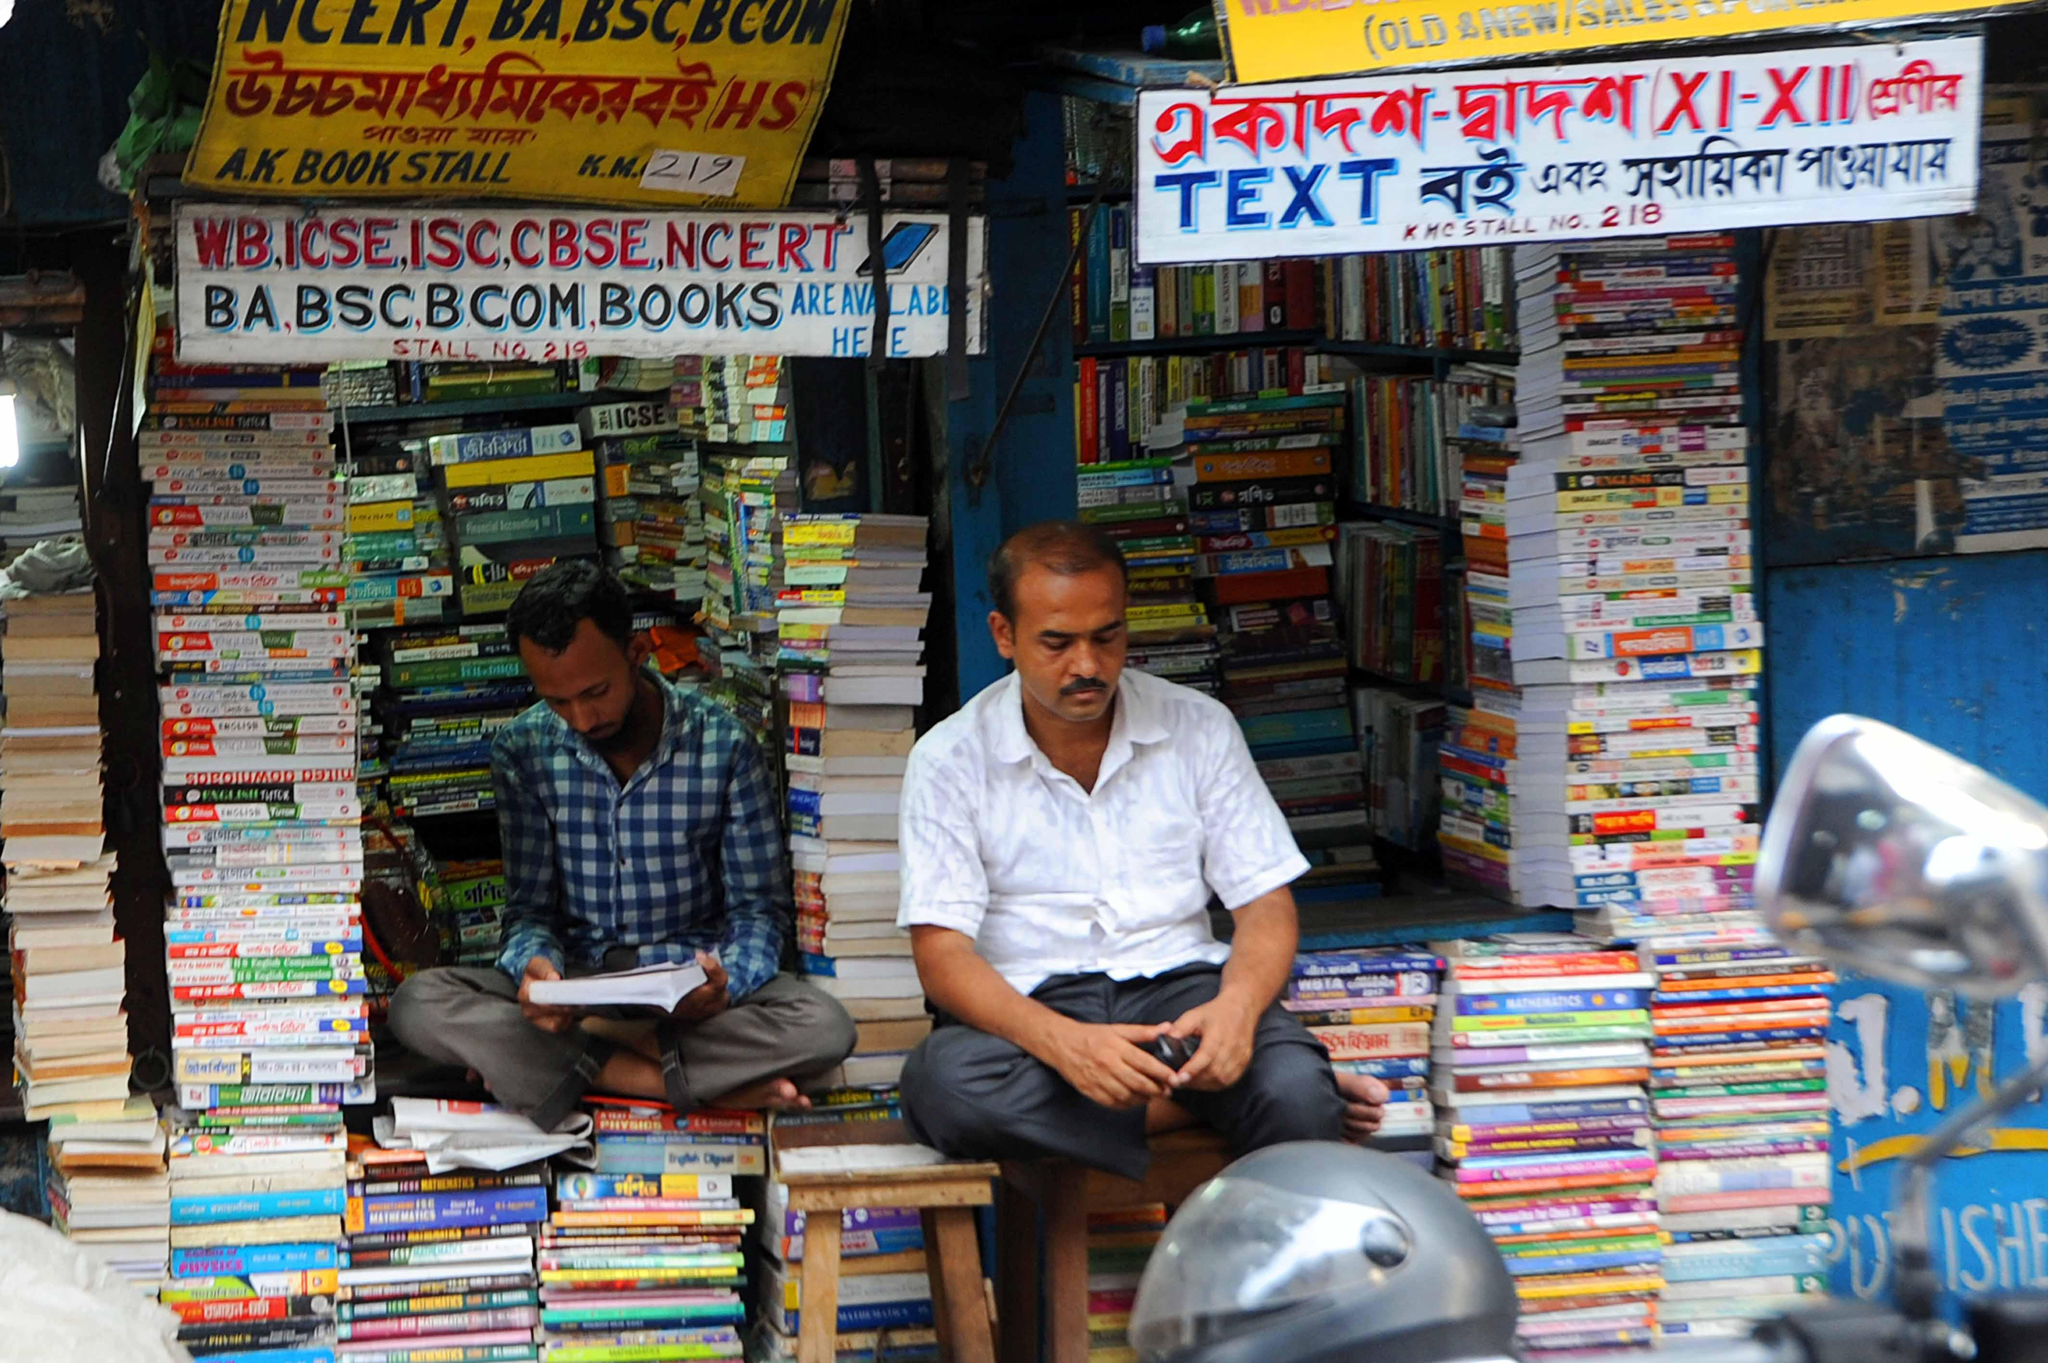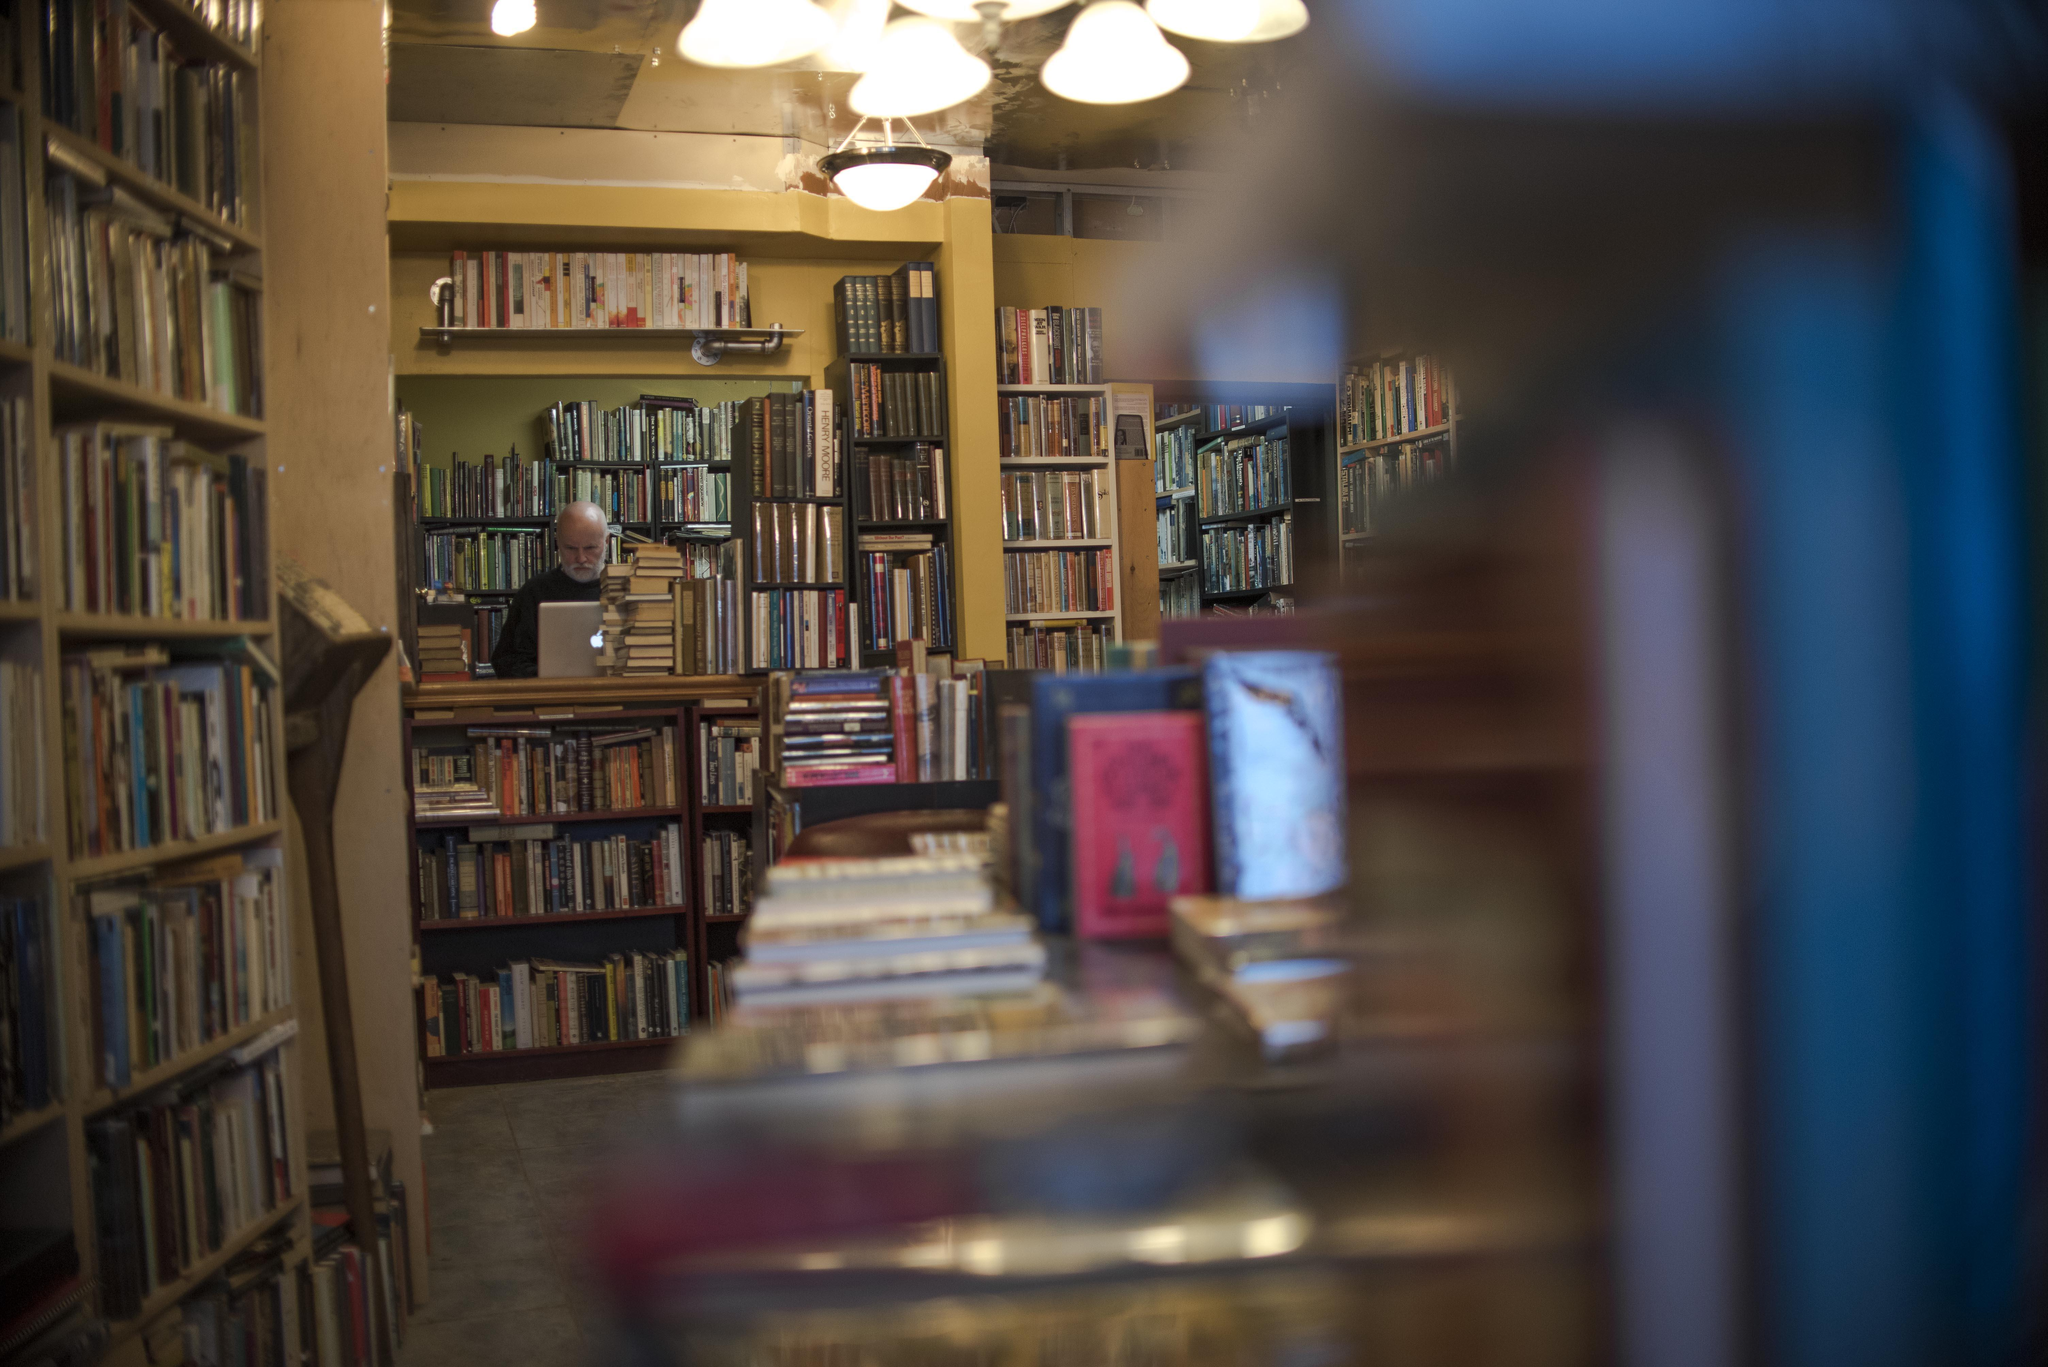The first image is the image on the left, the second image is the image on the right. For the images shown, is this caption "There are no more than 3 people at the book store." true? Answer yes or no. Yes. The first image is the image on the left, the second image is the image on the right. For the images shown, is this caption "One image shows a man in a light colored button up shirt sitting outside the store front next to piles of books." true? Answer yes or no. Yes. 